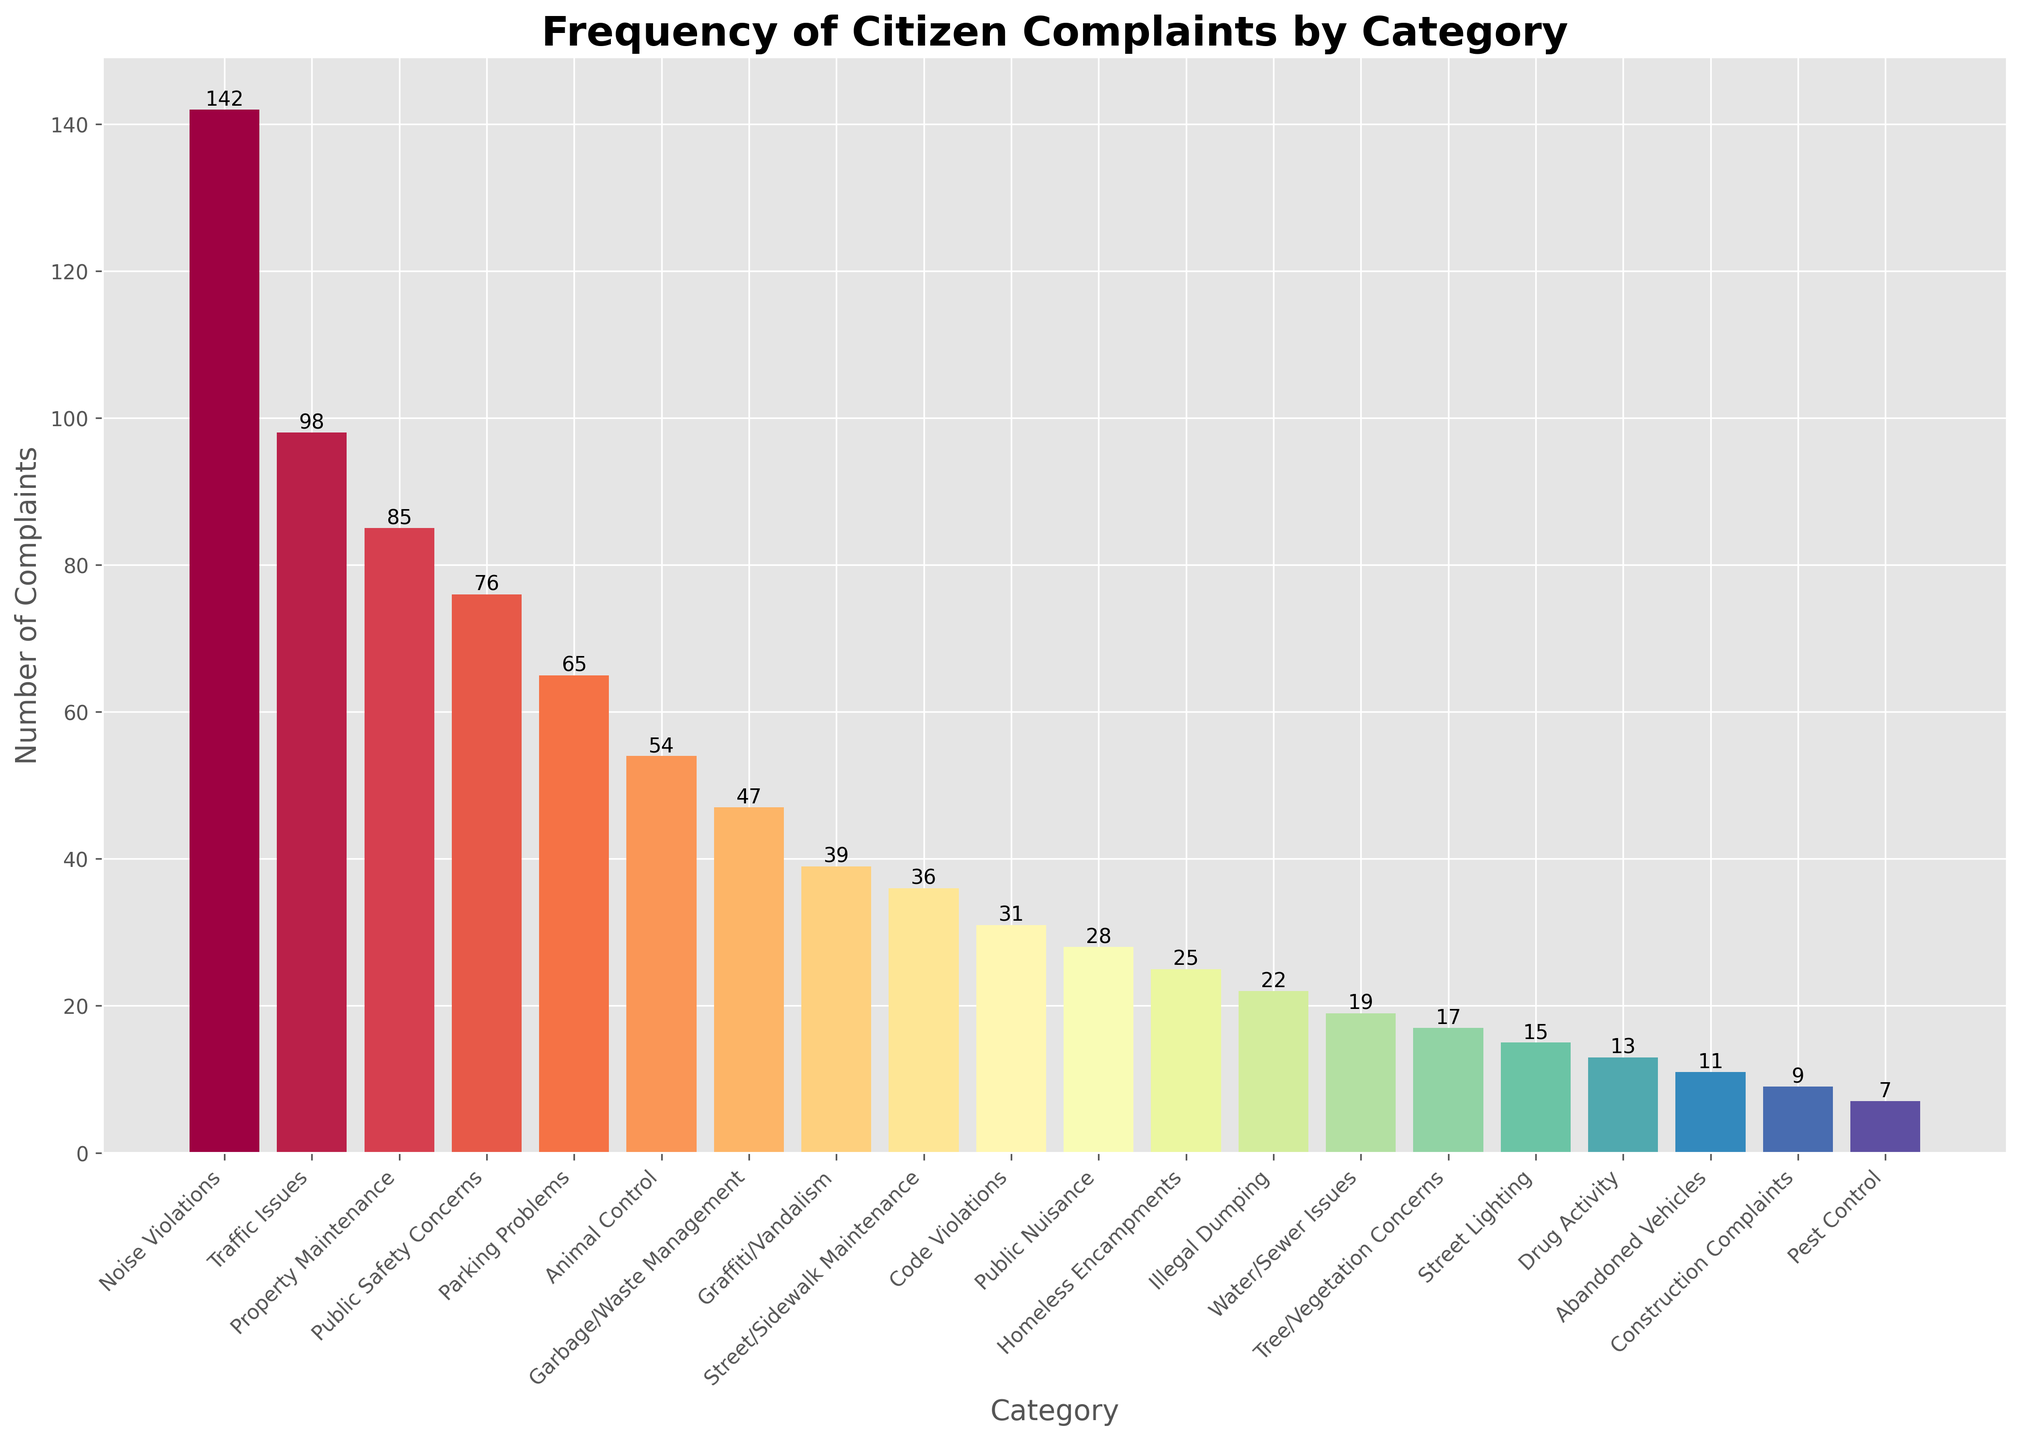Which category has the highest number of complaints? The category with the highest bar represents the highest number of complaints. The "Noise Violations" category has the tallest bar at 142 complaints.
Answer: Noise Violations What is the total number of complaints for Property Maintenance, Public Safety Concerns, and Parking Problems categories combined? Add up the complaints from the three specified categories: Property Maintenance (85), Public Safety Concerns (76), and Parking Problems (65). Thus, 85 + 76 + 65 = 226.
Answer: 226 How many more complaints does Noise Violations have compared to Traffic Issues? Subtract the number of Traffic Issues complaints from the number of Noise Violations complaints. Noise Violations have 142 complaints, and Traffic Issues have 98 complaints. So, 142 - 98 = 44.
Answer: 44 Which category has the least number of complaints? The category with the shortest bar represents the fewest complaints. The "Pest Control" category has the shortest bar with 7 complaints.
Answer: Pest Control Are there more complaints related to Public Nuisance or Illegal Dumping? Compare the height of the bars for Public Nuisance (28) and Illegal Dumping (22). Public Nuisance has more complaints.
Answer: Public Nuisance What is the average number of complaints for the categories with fewer than 20 complaints? Categories with fewer than 20 complaints are Water/Sewer Issues (19), Tree/Vegetation Concerns (17), Street Lighting (15), Drug Activity (13), Abandoned Vehicles (11), Construction Complaints (9), and Pest Control (7). Sum these complaints: 19 + 17 + 15 + 13 + 11 + 9 + 7 = 91. There are 7 categories, so the average is 91 / 7 = 13.
Answer: 13 Which two categories have the closest number of complaints to each other, and what are their counts? Look for categories with bars of similar heights: "Street/Sidewalk Maintenance" (36) and "Code Violations" (31) have the closest numbers.
Answer: Street/Sidewalk Maintenance (36) and Code Violations (31) What is the median number of complaints across all categories? Sort complaints in ascending order: 7, 9, 11, 13, 15, 17, 19, 22, 25, 28, 31, 36, 39, 47, 54, 65, 76, 85, 98, 142. The median is the middle value, which is the 10th and 11th values averaged: (28 + 31) / 2 = 29.5.
Answer: 29.5 